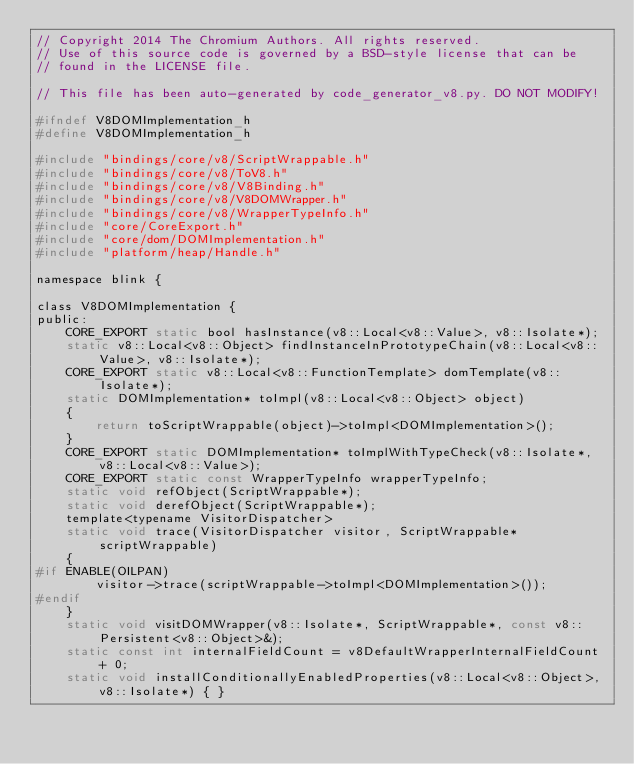Convert code to text. <code><loc_0><loc_0><loc_500><loc_500><_C_>// Copyright 2014 The Chromium Authors. All rights reserved.
// Use of this source code is governed by a BSD-style license that can be
// found in the LICENSE file.

// This file has been auto-generated by code_generator_v8.py. DO NOT MODIFY!

#ifndef V8DOMImplementation_h
#define V8DOMImplementation_h

#include "bindings/core/v8/ScriptWrappable.h"
#include "bindings/core/v8/ToV8.h"
#include "bindings/core/v8/V8Binding.h"
#include "bindings/core/v8/V8DOMWrapper.h"
#include "bindings/core/v8/WrapperTypeInfo.h"
#include "core/CoreExport.h"
#include "core/dom/DOMImplementation.h"
#include "platform/heap/Handle.h"

namespace blink {

class V8DOMImplementation {
public:
    CORE_EXPORT static bool hasInstance(v8::Local<v8::Value>, v8::Isolate*);
    static v8::Local<v8::Object> findInstanceInPrototypeChain(v8::Local<v8::Value>, v8::Isolate*);
    CORE_EXPORT static v8::Local<v8::FunctionTemplate> domTemplate(v8::Isolate*);
    static DOMImplementation* toImpl(v8::Local<v8::Object> object)
    {
        return toScriptWrappable(object)->toImpl<DOMImplementation>();
    }
    CORE_EXPORT static DOMImplementation* toImplWithTypeCheck(v8::Isolate*, v8::Local<v8::Value>);
    CORE_EXPORT static const WrapperTypeInfo wrapperTypeInfo;
    static void refObject(ScriptWrappable*);
    static void derefObject(ScriptWrappable*);
    template<typename VisitorDispatcher>
    static void trace(VisitorDispatcher visitor, ScriptWrappable* scriptWrappable)
    {
#if ENABLE(OILPAN)
        visitor->trace(scriptWrappable->toImpl<DOMImplementation>());
#endif
    }
    static void visitDOMWrapper(v8::Isolate*, ScriptWrappable*, const v8::Persistent<v8::Object>&);
    static const int internalFieldCount = v8DefaultWrapperInternalFieldCount + 0;
    static void installConditionallyEnabledProperties(v8::Local<v8::Object>, v8::Isolate*) { }</code> 